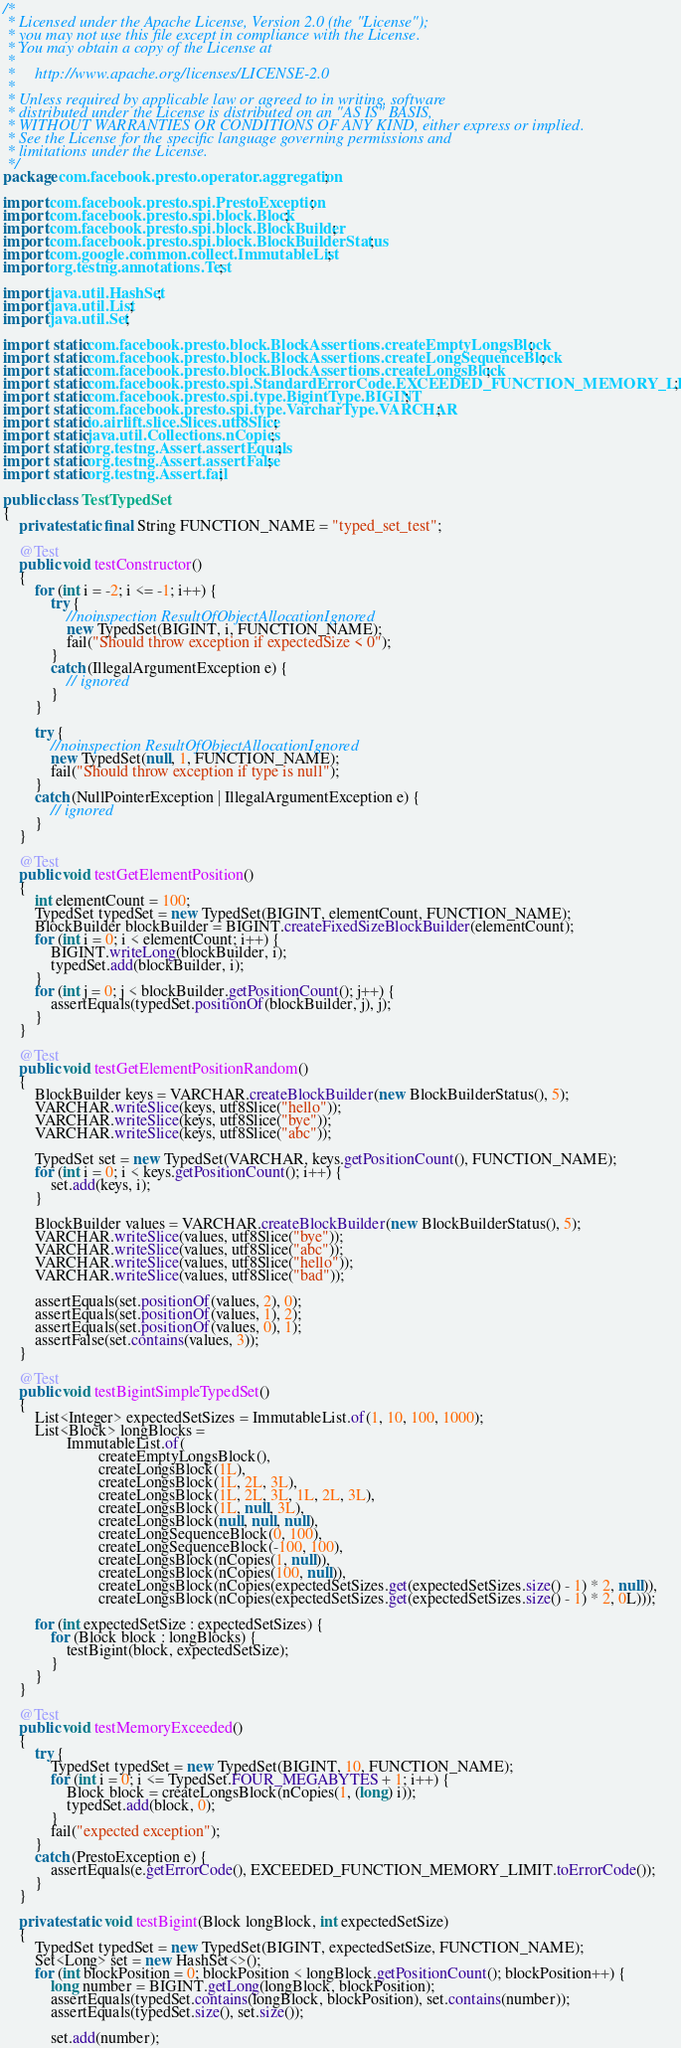Convert code to text. <code><loc_0><loc_0><loc_500><loc_500><_Java_>/*
 * Licensed under the Apache License, Version 2.0 (the "License");
 * you may not use this file except in compliance with the License.
 * You may obtain a copy of the License at
 *
 *     http://www.apache.org/licenses/LICENSE-2.0
 *
 * Unless required by applicable law or agreed to in writing, software
 * distributed under the License is distributed on an "AS IS" BASIS,
 * WITHOUT WARRANTIES OR CONDITIONS OF ANY KIND, either express or implied.
 * See the License for the specific language governing permissions and
 * limitations under the License.
 */
package com.facebook.presto.operator.aggregation;

import com.facebook.presto.spi.PrestoException;
import com.facebook.presto.spi.block.Block;
import com.facebook.presto.spi.block.BlockBuilder;
import com.facebook.presto.spi.block.BlockBuilderStatus;
import com.google.common.collect.ImmutableList;
import org.testng.annotations.Test;

import java.util.HashSet;
import java.util.List;
import java.util.Set;

import static com.facebook.presto.block.BlockAssertions.createEmptyLongsBlock;
import static com.facebook.presto.block.BlockAssertions.createLongSequenceBlock;
import static com.facebook.presto.block.BlockAssertions.createLongsBlock;
import static com.facebook.presto.spi.StandardErrorCode.EXCEEDED_FUNCTION_MEMORY_LIMIT;
import static com.facebook.presto.spi.type.BigintType.BIGINT;
import static com.facebook.presto.spi.type.VarcharType.VARCHAR;
import static io.airlift.slice.Slices.utf8Slice;
import static java.util.Collections.nCopies;
import static org.testng.Assert.assertEquals;
import static org.testng.Assert.assertFalse;
import static org.testng.Assert.fail;

public class TestTypedSet
{
    private static final String FUNCTION_NAME = "typed_set_test";

    @Test
    public void testConstructor()
    {
        for (int i = -2; i <= -1; i++) {
            try {
                //noinspection ResultOfObjectAllocationIgnored
                new TypedSet(BIGINT, i, FUNCTION_NAME);
                fail("Should throw exception if expectedSize < 0");
            }
            catch (IllegalArgumentException e) {
                // ignored
            }
        }

        try {
            //noinspection ResultOfObjectAllocationIgnored
            new TypedSet(null, 1, FUNCTION_NAME);
            fail("Should throw exception if type is null");
        }
        catch (NullPointerException | IllegalArgumentException e) {
            // ignored
        }
    }

    @Test
    public void testGetElementPosition()
    {
        int elementCount = 100;
        TypedSet typedSet = new TypedSet(BIGINT, elementCount, FUNCTION_NAME);
        BlockBuilder blockBuilder = BIGINT.createFixedSizeBlockBuilder(elementCount);
        for (int i = 0; i < elementCount; i++) {
            BIGINT.writeLong(blockBuilder, i);
            typedSet.add(blockBuilder, i);
        }
        for (int j = 0; j < blockBuilder.getPositionCount(); j++) {
            assertEquals(typedSet.positionOf(blockBuilder, j), j);
        }
    }

    @Test
    public void testGetElementPositionRandom()
    {
        BlockBuilder keys = VARCHAR.createBlockBuilder(new BlockBuilderStatus(), 5);
        VARCHAR.writeSlice(keys, utf8Slice("hello"));
        VARCHAR.writeSlice(keys, utf8Slice("bye"));
        VARCHAR.writeSlice(keys, utf8Slice("abc"));

        TypedSet set = new TypedSet(VARCHAR, keys.getPositionCount(), FUNCTION_NAME);
        for (int i = 0; i < keys.getPositionCount(); i++) {
            set.add(keys, i);
        }

        BlockBuilder values = VARCHAR.createBlockBuilder(new BlockBuilderStatus(), 5);
        VARCHAR.writeSlice(values, utf8Slice("bye"));
        VARCHAR.writeSlice(values, utf8Slice("abc"));
        VARCHAR.writeSlice(values, utf8Slice("hello"));
        VARCHAR.writeSlice(values, utf8Slice("bad"));

        assertEquals(set.positionOf(values, 2), 0);
        assertEquals(set.positionOf(values, 1), 2);
        assertEquals(set.positionOf(values, 0), 1);
        assertFalse(set.contains(values, 3));
    }

    @Test
    public void testBigintSimpleTypedSet()
    {
        List<Integer> expectedSetSizes = ImmutableList.of(1, 10, 100, 1000);
        List<Block> longBlocks =
                ImmutableList.of(
                        createEmptyLongsBlock(),
                        createLongsBlock(1L),
                        createLongsBlock(1L, 2L, 3L),
                        createLongsBlock(1L, 2L, 3L, 1L, 2L, 3L),
                        createLongsBlock(1L, null, 3L),
                        createLongsBlock(null, null, null),
                        createLongSequenceBlock(0, 100),
                        createLongSequenceBlock(-100, 100),
                        createLongsBlock(nCopies(1, null)),
                        createLongsBlock(nCopies(100, null)),
                        createLongsBlock(nCopies(expectedSetSizes.get(expectedSetSizes.size() - 1) * 2, null)),
                        createLongsBlock(nCopies(expectedSetSizes.get(expectedSetSizes.size() - 1) * 2, 0L)));

        for (int expectedSetSize : expectedSetSizes) {
            for (Block block : longBlocks) {
                testBigint(block, expectedSetSize);
            }
        }
    }

    @Test
    public void testMemoryExceeded()
    {
        try {
            TypedSet typedSet = new TypedSet(BIGINT, 10, FUNCTION_NAME);
            for (int i = 0; i <= TypedSet.FOUR_MEGABYTES + 1; i++) {
                Block block = createLongsBlock(nCopies(1, (long) i));
                typedSet.add(block, 0);
            }
            fail("expected exception");
        }
        catch (PrestoException e) {
            assertEquals(e.getErrorCode(), EXCEEDED_FUNCTION_MEMORY_LIMIT.toErrorCode());
        }
    }

    private static void testBigint(Block longBlock, int expectedSetSize)
    {
        TypedSet typedSet = new TypedSet(BIGINT, expectedSetSize, FUNCTION_NAME);
        Set<Long> set = new HashSet<>();
        for (int blockPosition = 0; blockPosition < longBlock.getPositionCount(); blockPosition++) {
            long number = BIGINT.getLong(longBlock, blockPosition);
            assertEquals(typedSet.contains(longBlock, blockPosition), set.contains(number));
            assertEquals(typedSet.size(), set.size());

            set.add(number);</code> 